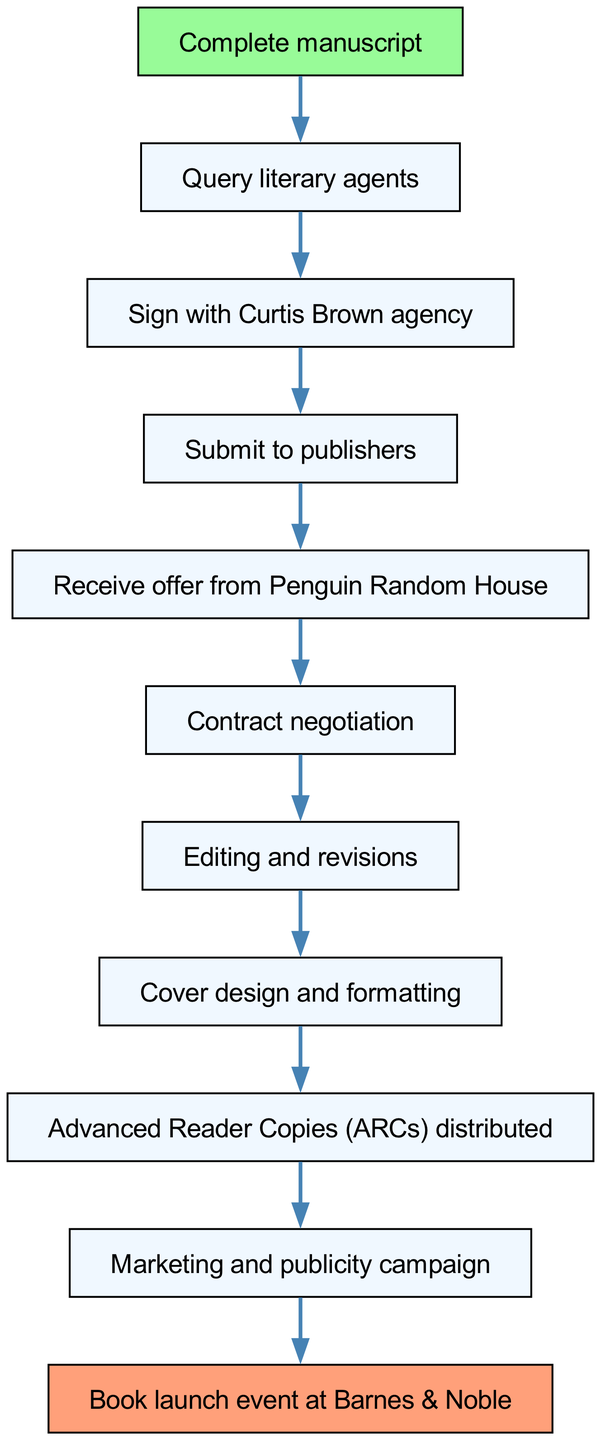What is the first step in the publishing journey? The first step is labeled "Complete manuscript," which indicates that having a completed manuscript is necessary before proceeding to the next steps.
Answer: Complete manuscript How many total steps are there in the diagram? Counting the nodes in the diagram, there are eleven distinct steps, ranging from completing the manuscript to the book launch event.
Answer: 11 What agency was signed with after querying literary agents? According to the diagram, after querying literary agents, the next step indicates signing with "Curtis Brown agency."
Answer: Curtis Brown agency What event marks the final step of the publishing journey? The final node in the diagram shows "Book launch event at Barnes & Noble," signifying the culmination of the publishing process.
Answer: Book launch event at Barnes & Noble Which publisher made an offer after the submission? The flow diagram states that "Penguin Random House" is the publisher that made an offer after the manuscript was submitted.
Answer: Penguin Random House What is the relationship between editing and revisions and contract negotiation? The diagram shows a directional flow where "Contract negotiation" directly precedes "Editing and revisions," indicating that contract negotiation occurs first before editing begins.
Answer: Contract negotiation precedes editing and revisions What step directly follows the distribution of Advanced Reader Copies? The step that follows the distribution of Advanced Reader Copies (ARCs) is labeled "Marketing and publicity campaign," indicating that marketing efforts begin after ARCs have been distributed.
Answer: Marketing and publicity campaign How many nodes indicate the process of editing and preparation before the book launch? There are four nodes detailing the process before the book launch: "Contract negotiation," "Editing and revisions," "Cover design and formatting," and "Advanced Reader Copies (ARCs) distributed." Thus, the total count is four.
Answer: 4 What color represents the "Complete manuscript" node in the diagram? The diagram uses a specific fill color for the "Complete manuscript" node, which is identified as "#98FB98" (light green).
Answer: #98FB98 